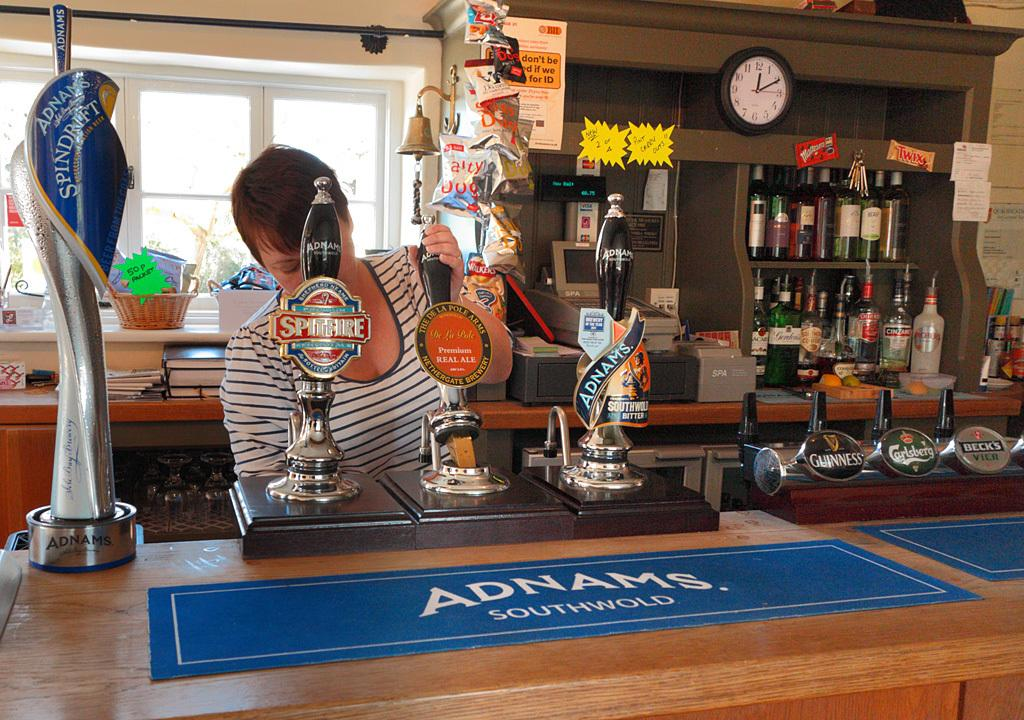<image>
Summarize the visual content of the image. The bartender is pulling the lever of De La Pole Premium Ale. 